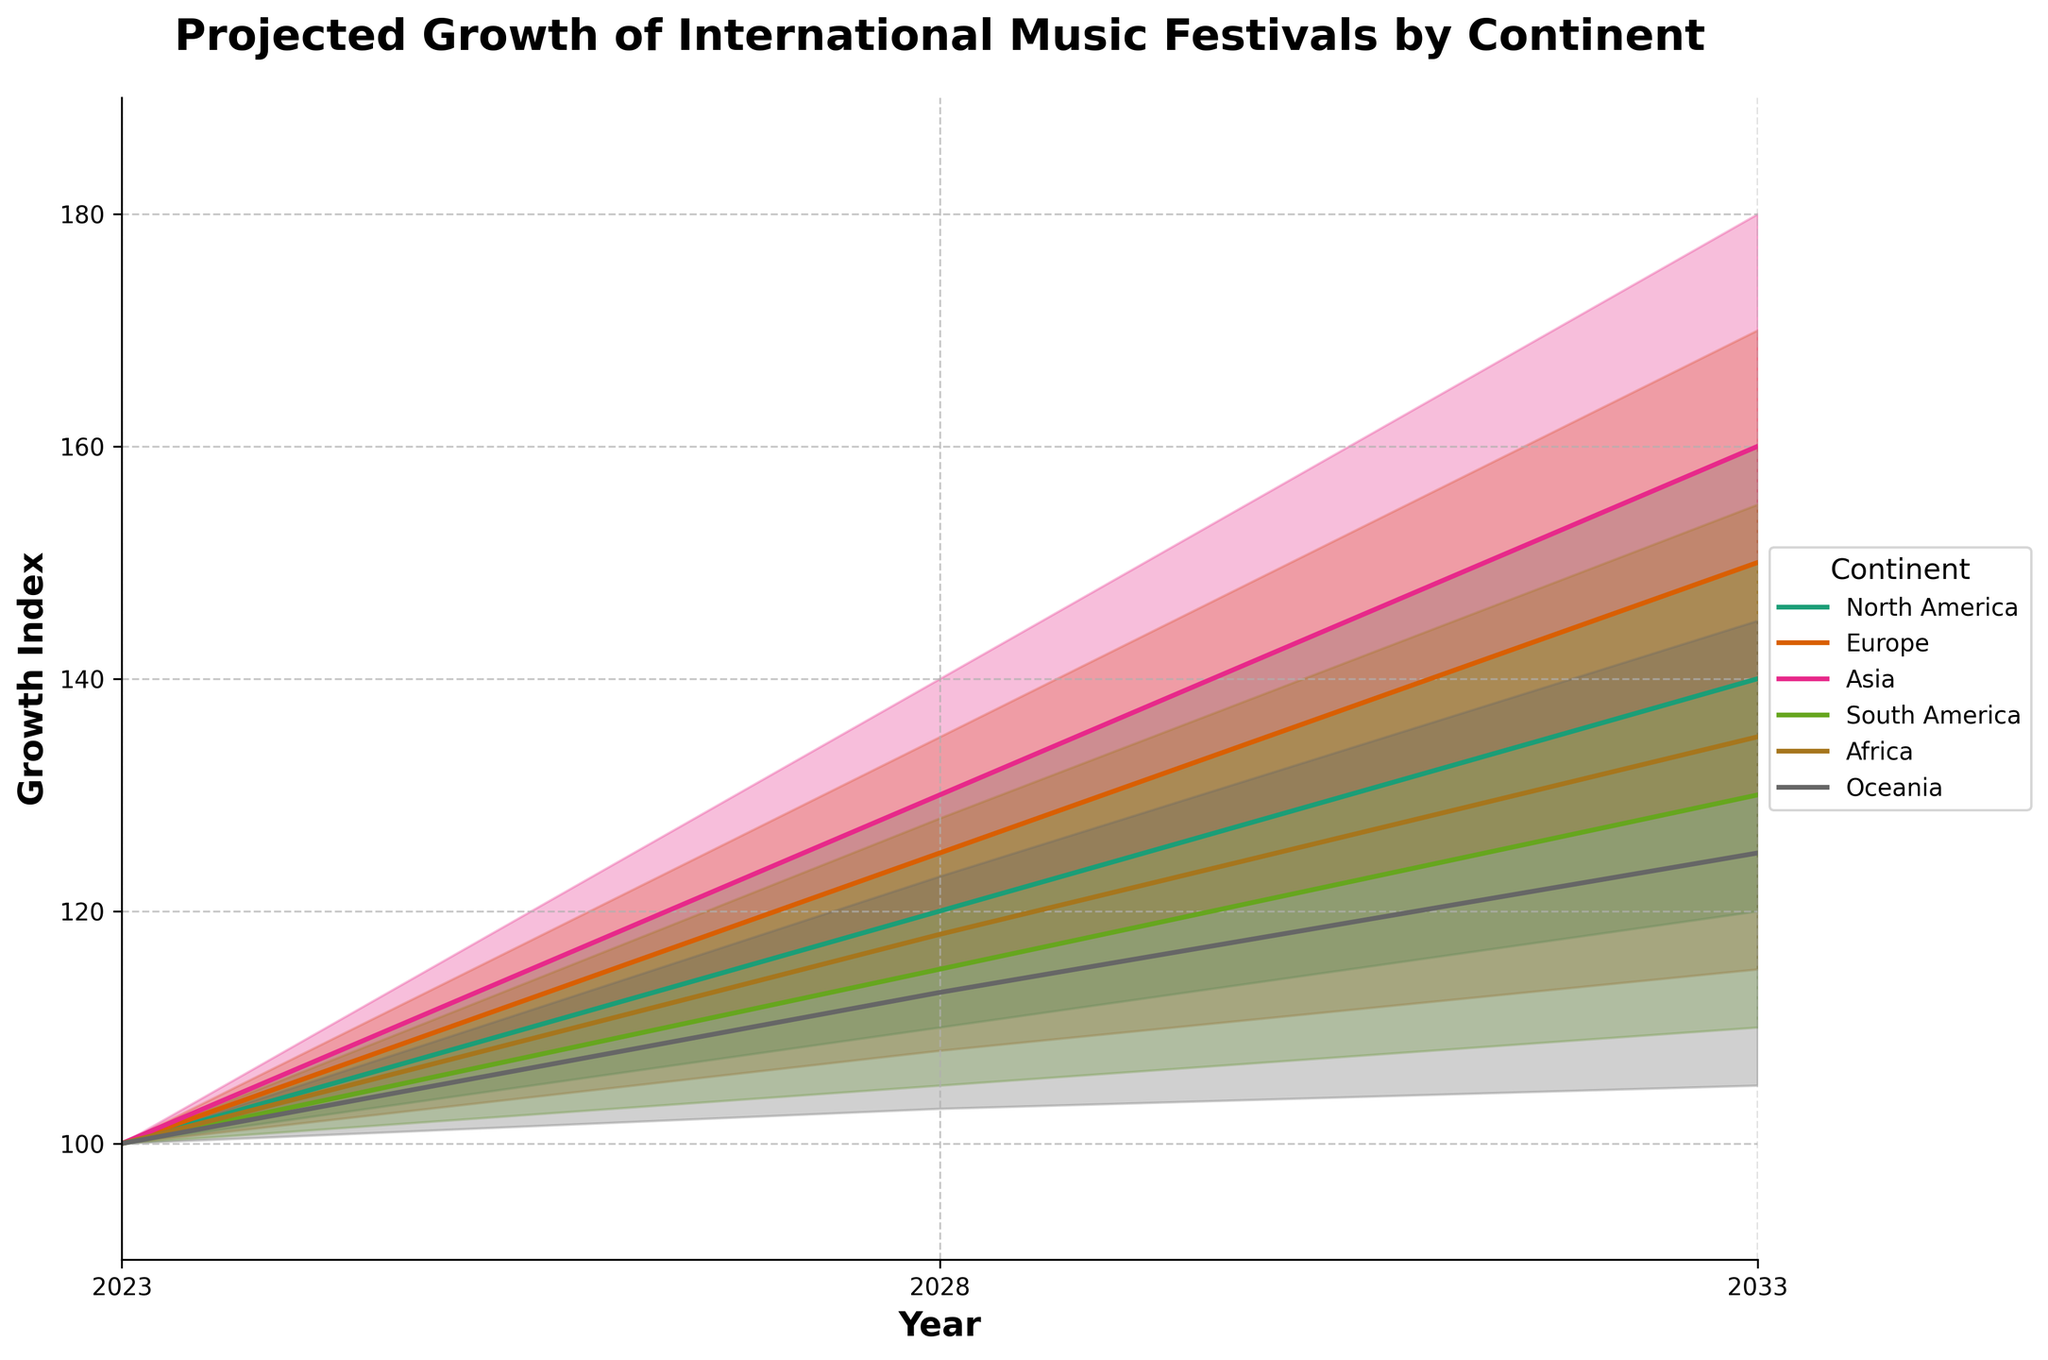What is the title of the figure? The title provides the main topic or subject that the figure represents. It is usually found at the top of the chart.
Answer: Projected Growth of International Music Festivals by Continent How many continents are represented in the figure? The legend on the graph indicates the number of unique categories represented, showing the continents with different colors.
Answer: 6 What is the estimated growth index for Asia in 2033 according to the mid estimate? The mid estimate values are represented by the central line within the shaded area. For the year 2033, find the specific value for Asia on this line.
Answer: 160 Between which years is the data projected? Look at the x-axis to identify the range of years covered in the projection.
Answer: 2023 to 2033 Which continent is projected to have the highest growth index by 2033 according to the high estimate? The high estimate is represented by the upper boundary of the shaded area. Look for the highest value in 2033 among all continents.
Answer: Asia What is the difference between the high estimate and low estimate for Europe in 2028? Find the high estimate and low estimate values for Europe in 2028 and subtract the low estimate from the high estimate to get the difference.
Answer: 20 Which continent has the smallest predicted growth range by 2033? The growth range is the difference between the high estimate and low estimate. Check the range (high estimate - low estimate) for each continent in 2033 and identify the smallest one.
Answer: Oceania How does the growth index for South America change from 2023 to 2033 according to the mid estimate? Identify the mid estimate values for South America in the years 2023 and 2033, then calculate the difference between these two values.
Answer: Increases by 30 Which continent shows a gradual increase from 2023 to 2033 with the least volatility in its estimates? Examine the growth patterns for each continent and identify the one with the most consistent increase and the smallest range between low and high estimates across the years.
Answer: Oceania Is there any continent that shows a decrease in estimated growth from 2028 to 2033 according to any estimate? Compare the low, mid, and high estimates for each continent between 2028 and 2033 to see if any show a reduction.
Answer: No 